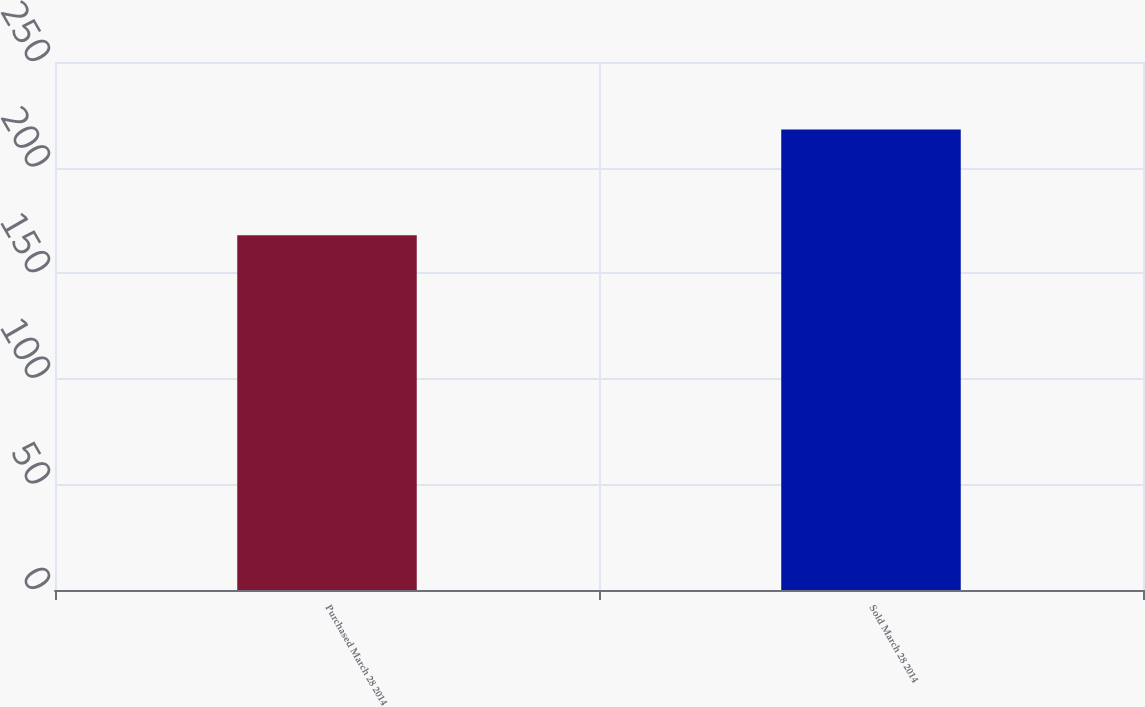<chart> <loc_0><loc_0><loc_500><loc_500><bar_chart><fcel>Purchased March 28 2014<fcel>Sold March 28 2014<nl><fcel>168<fcel>218<nl></chart> 